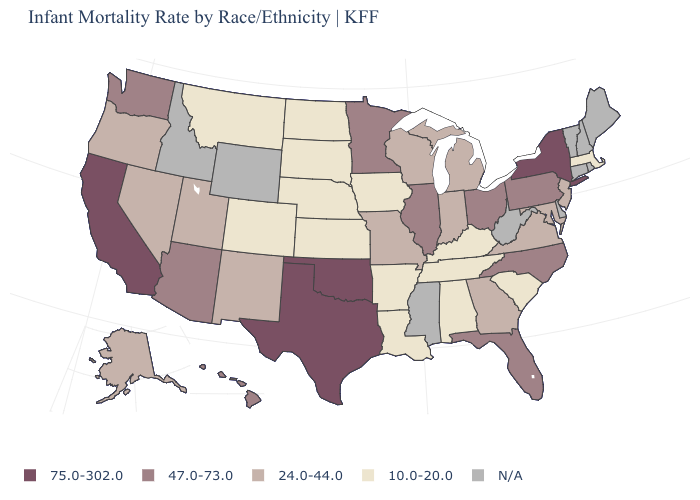What is the value of Oregon?
Give a very brief answer. 24.0-44.0. What is the value of Arizona?
Give a very brief answer. 47.0-73.0. Among the states that border Pennsylvania , which have the highest value?
Answer briefly. New York. What is the lowest value in the USA?
Answer briefly. 10.0-20.0. Name the states that have a value in the range 47.0-73.0?
Quick response, please. Arizona, Florida, Hawaii, Illinois, Minnesota, North Carolina, Ohio, Pennsylvania, Washington. What is the value of Utah?
Write a very short answer. 24.0-44.0. Name the states that have a value in the range N/A?
Quick response, please. Connecticut, Delaware, Idaho, Maine, Mississippi, New Hampshire, Rhode Island, Vermont, West Virginia, Wyoming. Does the map have missing data?
Concise answer only. Yes. Name the states that have a value in the range 75.0-302.0?
Be succinct. California, New York, Oklahoma, Texas. What is the value of North Carolina?
Write a very short answer. 47.0-73.0. What is the lowest value in the USA?
Concise answer only. 10.0-20.0. Which states have the highest value in the USA?
Quick response, please. California, New York, Oklahoma, Texas. What is the value of Rhode Island?
Write a very short answer. N/A. What is the lowest value in states that border California?
Give a very brief answer. 24.0-44.0. 